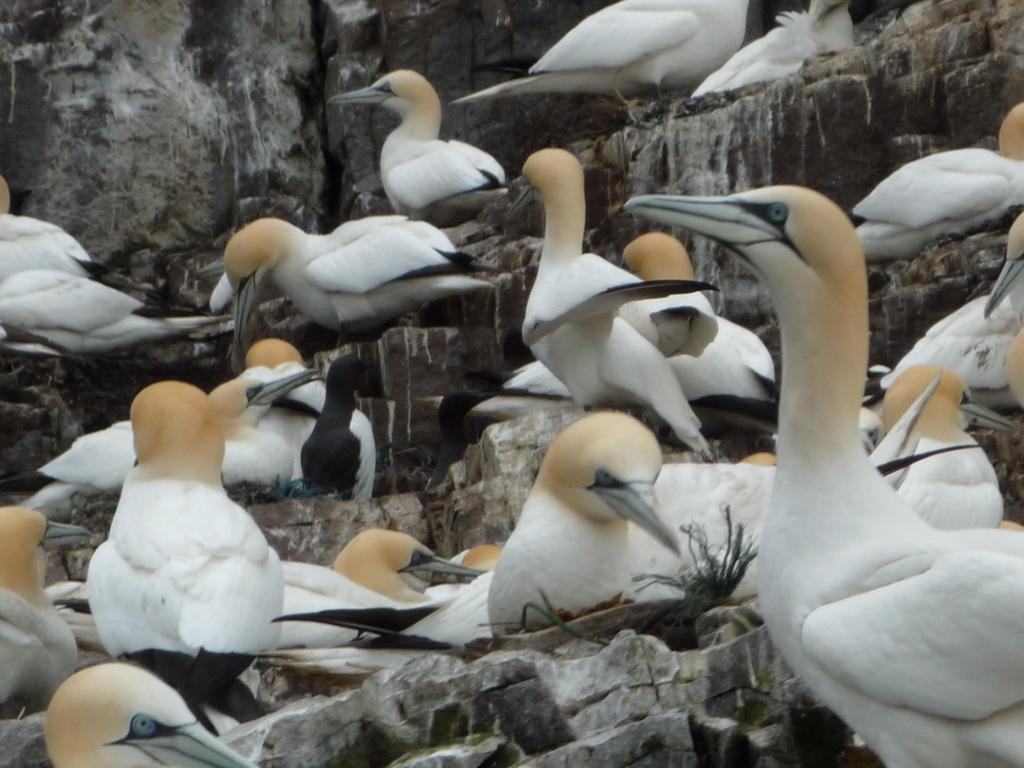What type of animals can be seen in the image? There are birds in the image. What colors are the birds in the image? The birds are in brown and white colors. What is located at the bottom of the image? There are rocks at the bottom of the image. What type of insurance policy do the birds have in the image? There is no mention of insurance in the image, and the birds do not have any visible insurance policies. How does the cloud affect the birds' flight in the image? There is no cloud present in the image, so its effect on the birds' flight cannot be determined. 